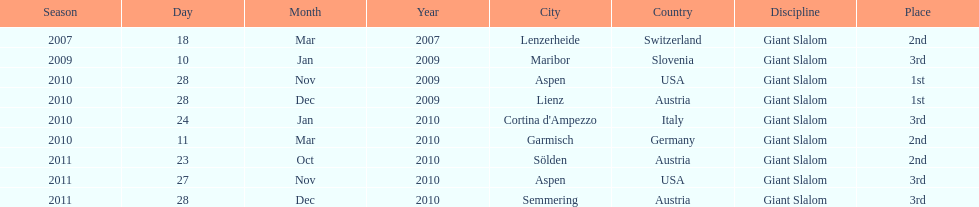Aspen and lienz in 2009 are the only races where this racer got what position? 1st. 